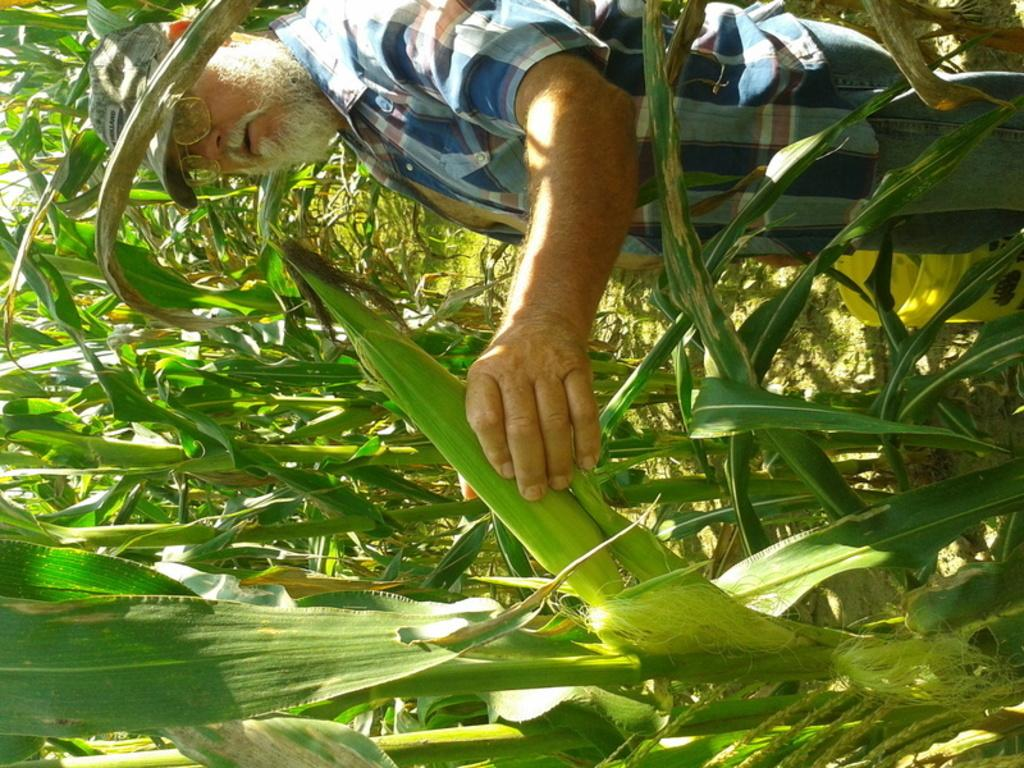Who is present in the image? There is a man in the image. What is the man doing in the image? The man is standing in the image. What is the man holding in the image? The man is holding maize in the image. What else can be seen in the image besides the man? There are plants in the image. What type of hose is being used to water the plants in the image? There is no hose present in the image; the man is holding maize, not a hose. 